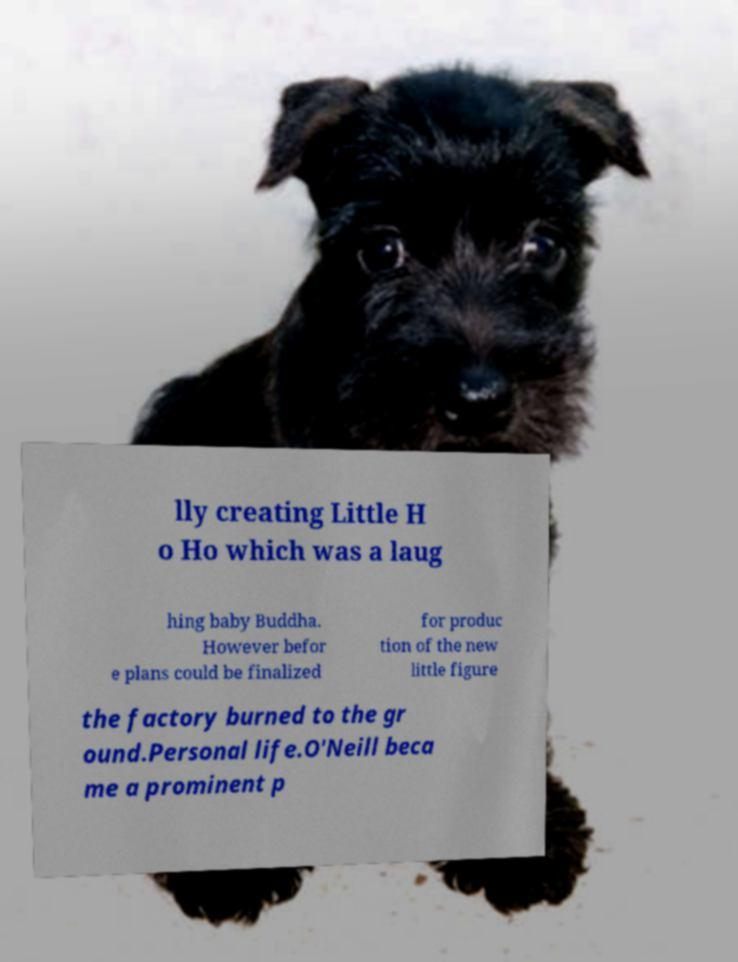Could you extract and type out the text from this image? lly creating Little H o Ho which was a laug hing baby Buddha. However befor e plans could be finalized for produc tion of the new little figure the factory burned to the gr ound.Personal life.O'Neill beca me a prominent p 